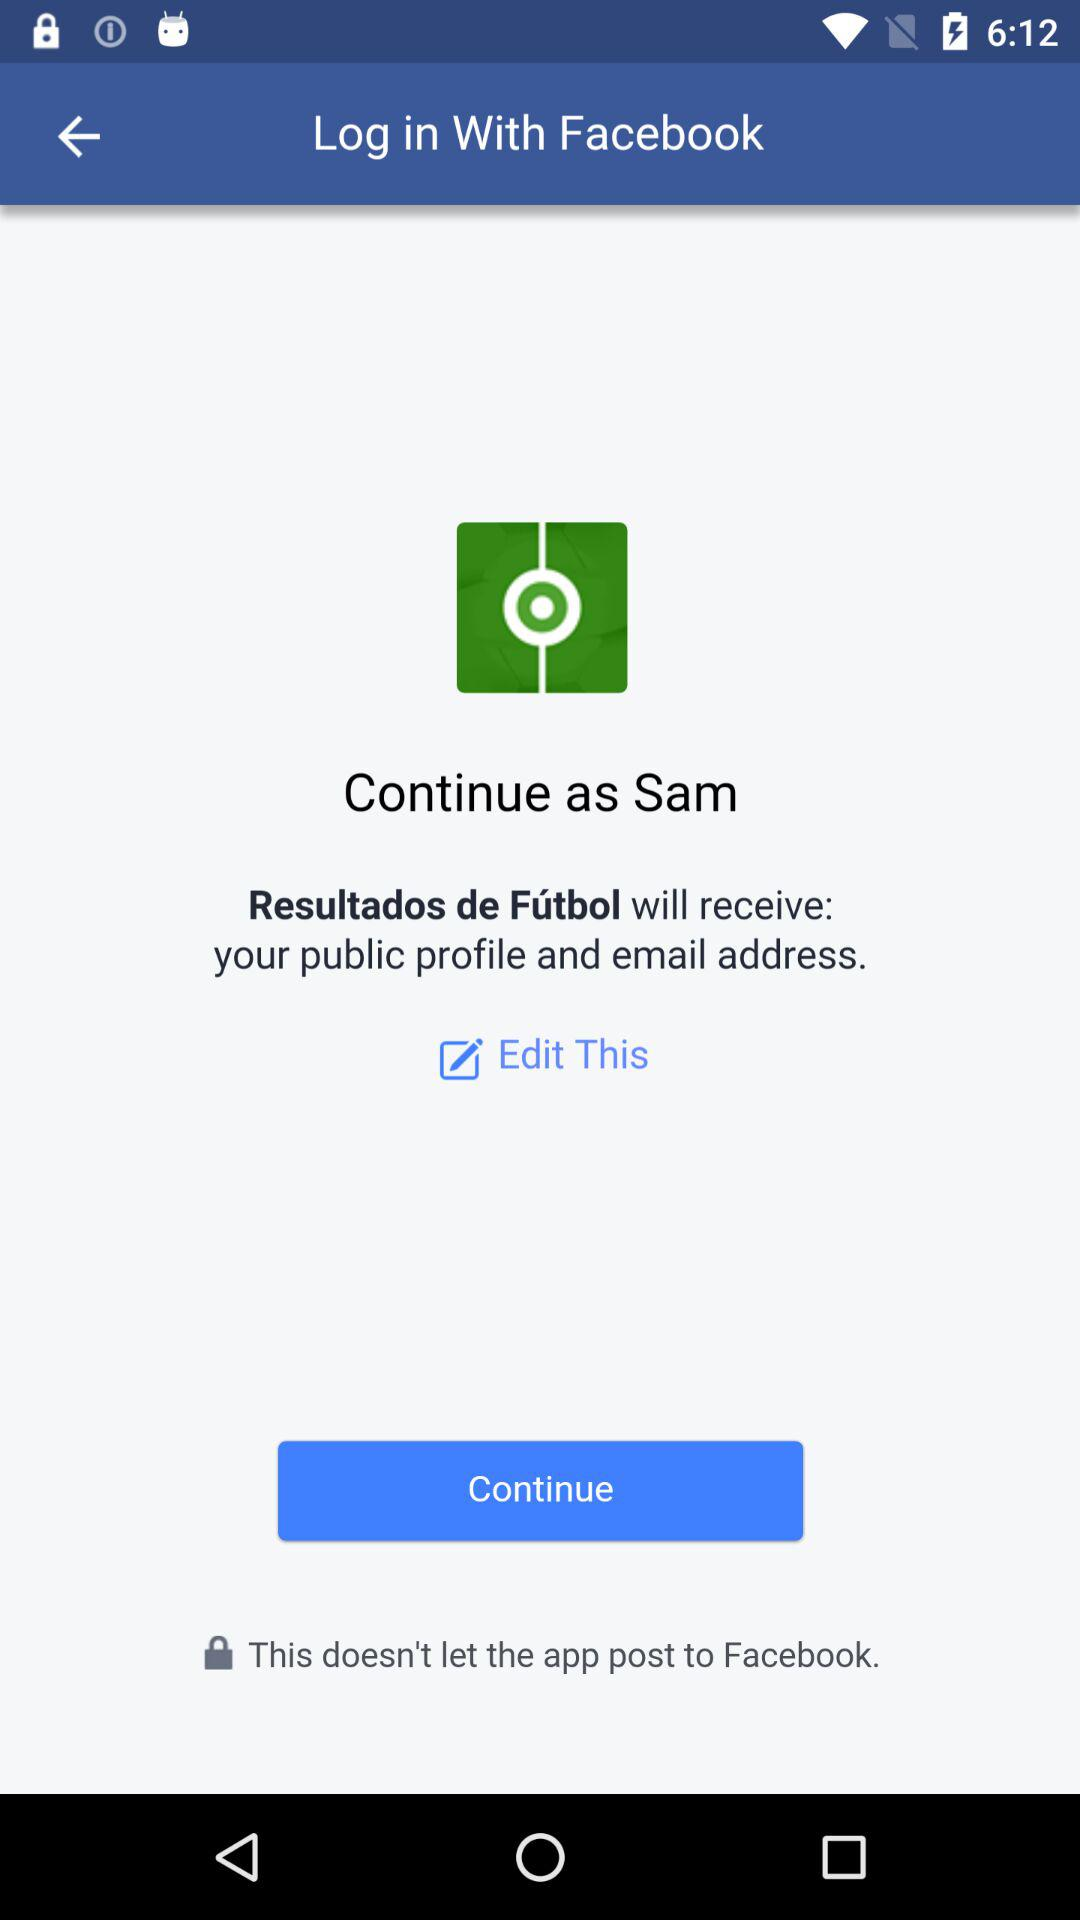How can we login? We can login through Facebook. 